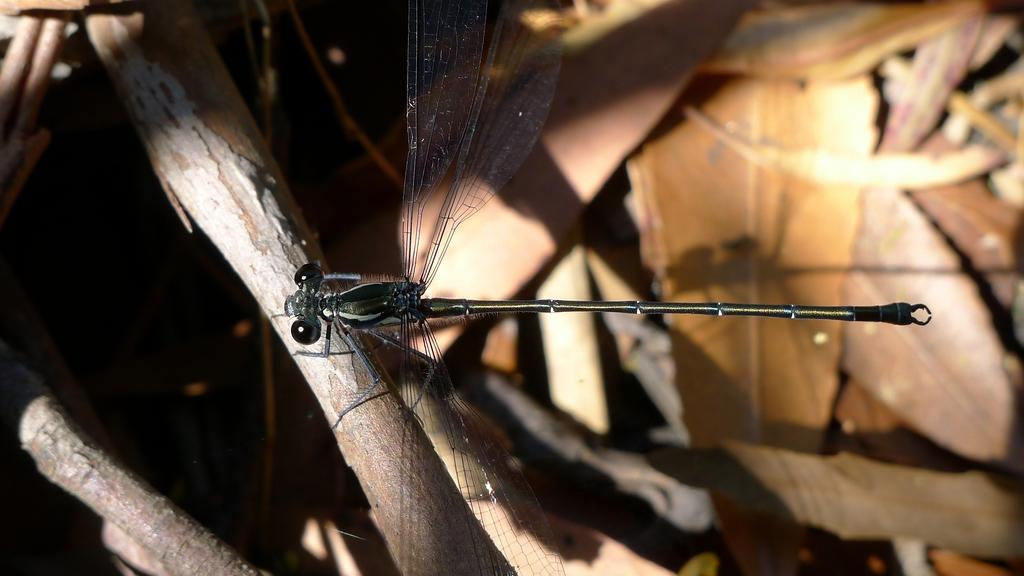What type of creature can be seen in the image? There is an insect in the image. What type of plant material is present in the image? There are leaves in the image. Where is the man sitting on the coach in the image? There is no man sitting on a coach in the image; it only features an insect and leaves. 